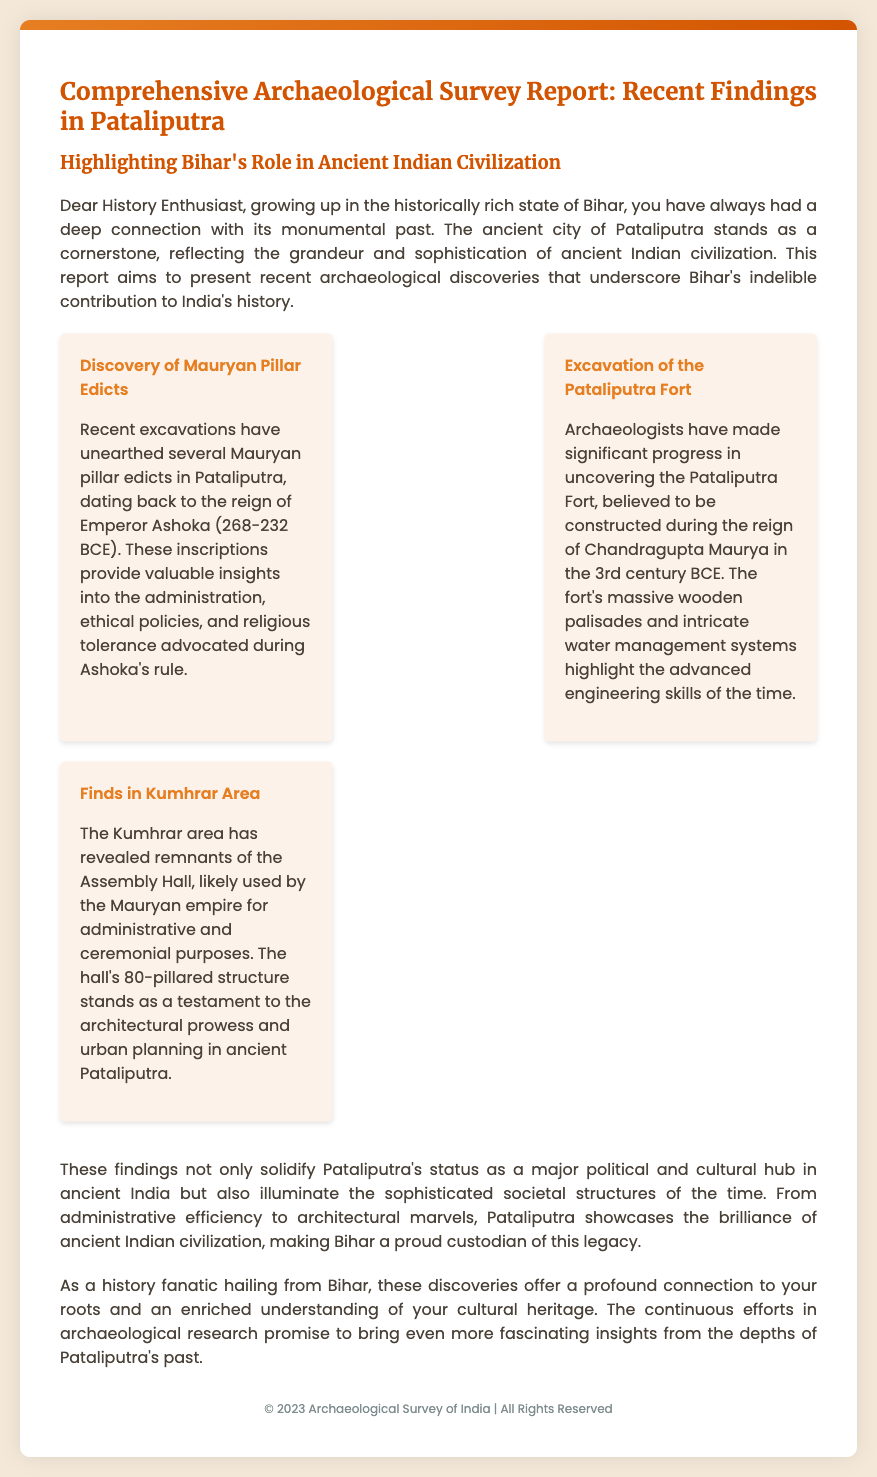What is the title of the report? The title of the report is found in the header of the document, stating the purpose of the report on Pataliputra.
Answer: Comprehensive Archaeological Survey Report: Recent Findings in Pataliputra Who was the Emperor during which the Mauryan pillar edicts were made? The report specifies the reign of the Mauryan pillar edicts found in Pataliputra, specifically mentioning the emperor associated with them.
Answer: Ashoka What century is the Pataliputra Fort believed to have been constructed? The document mentions the era of the fort's construction, which is key in understanding the timeline of ancient Indian architecture.
Answer: 3rd century BCE How many pillars are in the Assembly Hall found in the Kumhrar area? The report outlines the structure of the Assembly Hall, providing specific details about its architectural features.
Answer: 80 What is highlighted as a significant aspect of ancient Pataliputra in the findings? The document points out important elements that showcase the city’s prominence in ancient times, including social and cultural aspects.
Answer: Architectural prowess What does the report say about Bihar’s role in Indian civilization? The introduction summarizes the importance of Bihar in the context of Indian history and how the findings reflect this impact.
Answer: Indelible contribution Which area revealed the remnants of the Assembly Hall? The findings section specifies a particular area that yielded important archaeological discoveries associated with the Mauryan empire.
Answer: Kumhrar What type of document is this? The structure and contents of the report indicate the nature and purpose of the document, identifying it clearly.
Answer: Archaeological Survey Report 